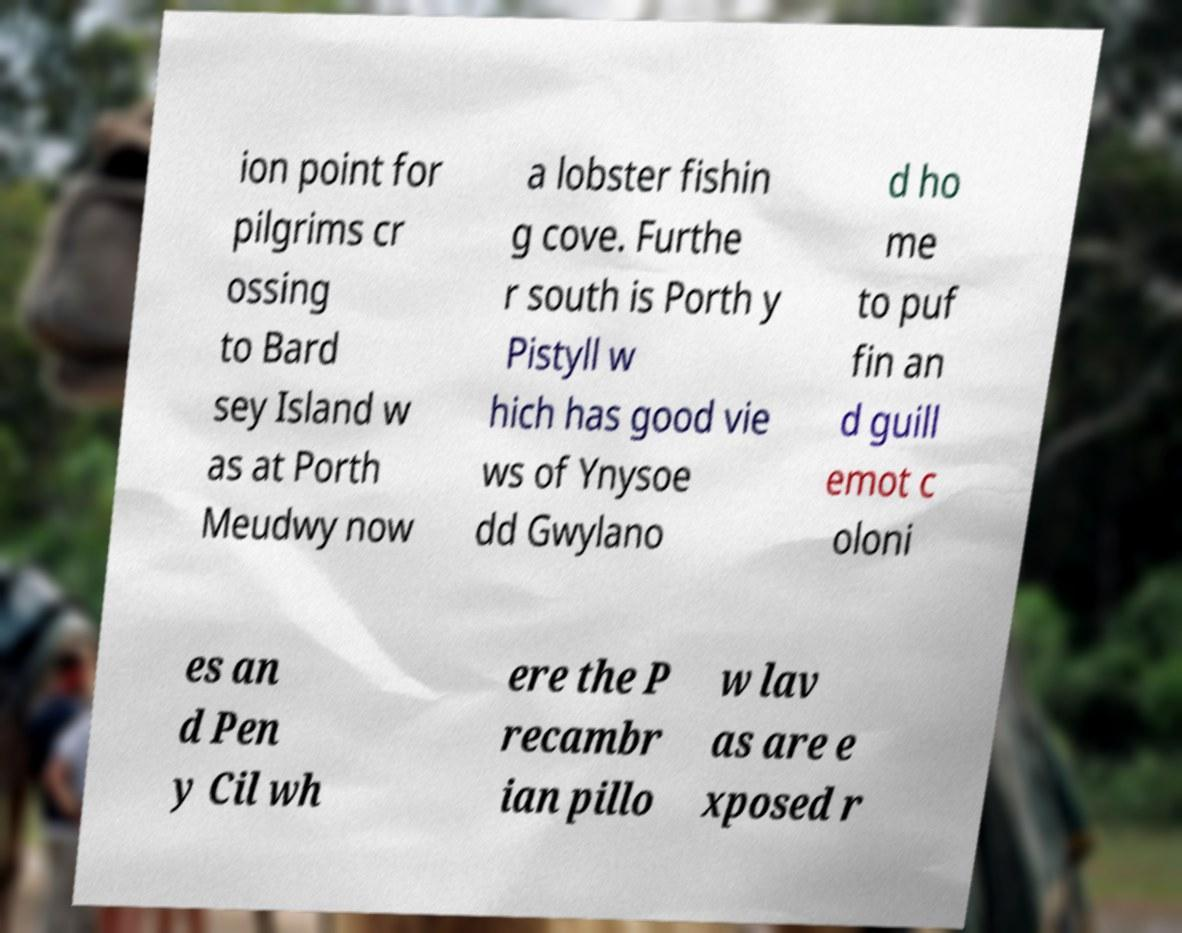Can you accurately transcribe the text from the provided image for me? ion point for pilgrims cr ossing to Bard sey Island w as at Porth Meudwy now a lobster fishin g cove. Furthe r south is Porth y Pistyll w hich has good vie ws of Ynysoe dd Gwylano d ho me to puf fin an d guill emot c oloni es an d Pen y Cil wh ere the P recambr ian pillo w lav as are e xposed r 